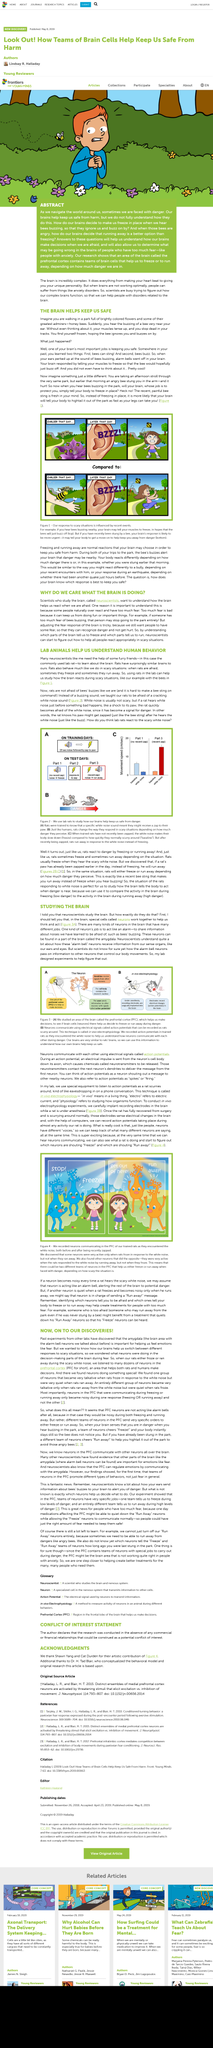Draw attention to some important aspects in this diagram. In their experiment, scientists used white noise and immediately followed it up with an electrical zap to instill fear in rats. The rats had to fully recover from the effects of surgery before they were able to resume scurrying around. The neurons in Figure 4 want to perform either the action of freezing or the action of running away. In vivo refers to a living thing or something that occurs within a living organism. The neuroscientist's study was conducted to investigate how the brain responds in frightening situations. 